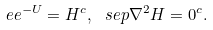<formula> <loc_0><loc_0><loc_500><loc_500>\ e e ^ { - U } = H ^ { c } , \ s e p \nabla ^ { 2 } H = 0 ^ { c } .</formula> 